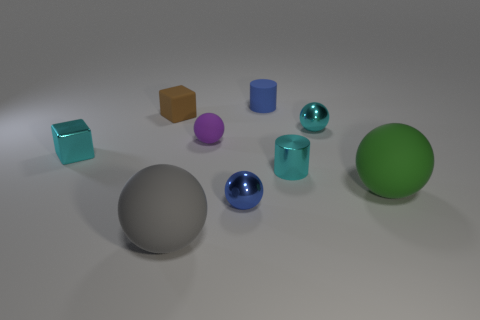Subtract all green balls. How many balls are left? 4 Subtract all small cyan balls. How many balls are left? 4 Subtract all gray balls. Subtract all brown cubes. How many balls are left? 4 Subtract all cylinders. How many objects are left? 7 Subtract all shiny cylinders. Subtract all brown blocks. How many objects are left? 7 Add 3 gray objects. How many gray objects are left? 4 Add 3 large blue metal objects. How many large blue metal objects exist? 3 Subtract 1 blue balls. How many objects are left? 8 